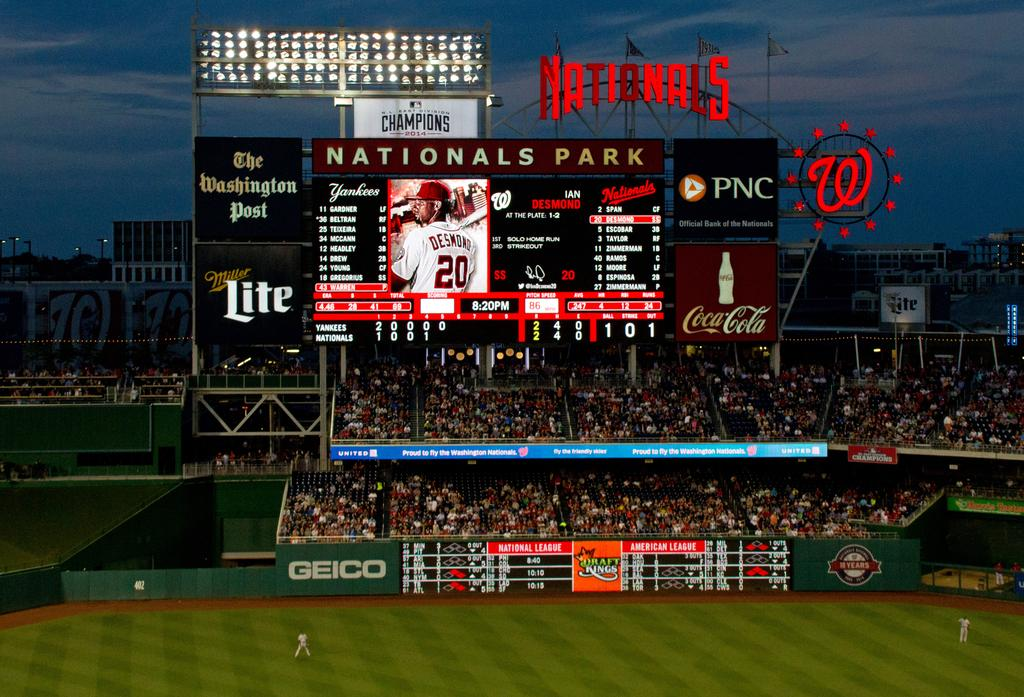<image>
Create a compact narrative representing the image presented. Scoreboard inside Nationals Park which is sponsored by Coca Cola. 